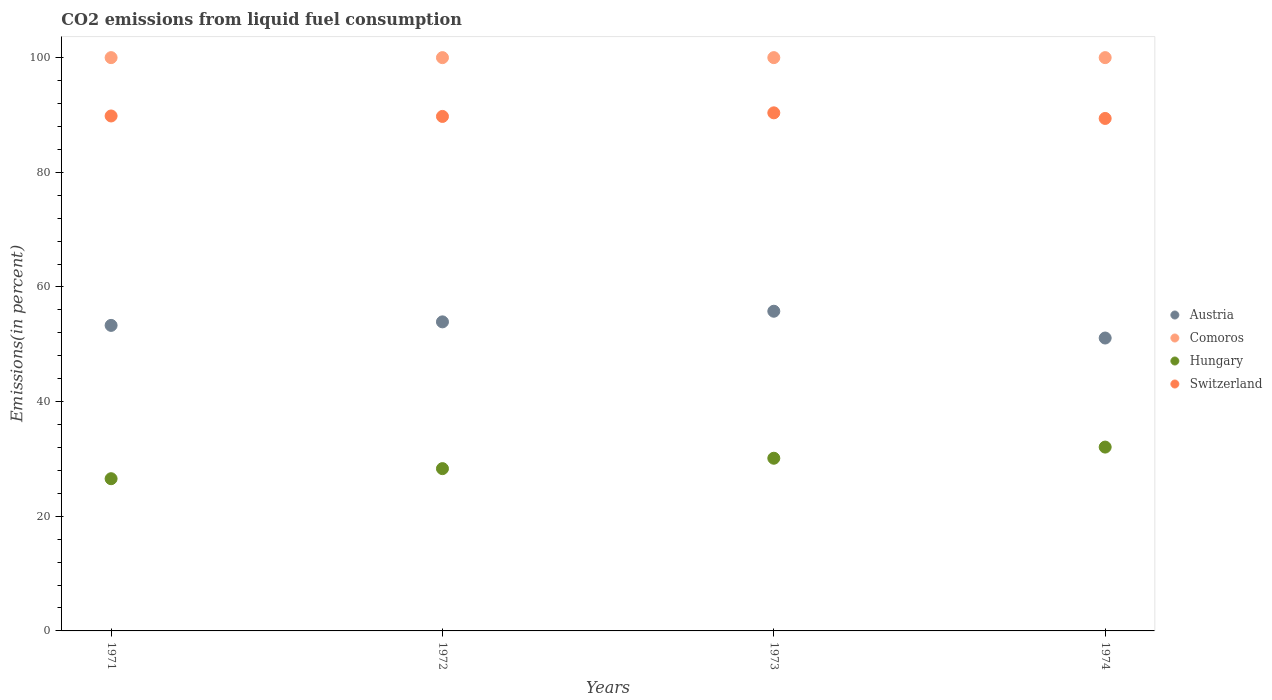How many different coloured dotlines are there?
Keep it short and to the point. 4. What is the total CO2 emitted in Hungary in 1971?
Offer a terse response. 26.55. Across all years, what is the maximum total CO2 emitted in Switzerland?
Give a very brief answer. 90.37. Across all years, what is the minimum total CO2 emitted in Austria?
Your answer should be very brief. 51.09. In which year was the total CO2 emitted in Austria maximum?
Your response must be concise. 1973. In which year was the total CO2 emitted in Switzerland minimum?
Ensure brevity in your answer.  1974. What is the total total CO2 emitted in Switzerland in the graph?
Provide a succinct answer. 359.33. What is the difference between the total CO2 emitted in Hungary in 1972 and that in 1973?
Provide a succinct answer. -1.81. What is the difference between the total CO2 emitted in Austria in 1971 and the total CO2 emitted in Switzerland in 1972?
Give a very brief answer. -36.45. What is the average total CO2 emitted in Switzerland per year?
Provide a short and direct response. 89.83. In the year 1973, what is the difference between the total CO2 emitted in Switzerland and total CO2 emitted in Austria?
Offer a very short reply. 34.61. What is the ratio of the total CO2 emitted in Switzerland in 1972 to that in 1974?
Provide a succinct answer. 1. Is the difference between the total CO2 emitted in Switzerland in 1972 and 1973 greater than the difference between the total CO2 emitted in Austria in 1972 and 1973?
Make the answer very short. Yes. What is the difference between the highest and the second highest total CO2 emitted in Hungary?
Provide a short and direct response. 1.95. What is the difference between the highest and the lowest total CO2 emitted in Comoros?
Provide a short and direct response. 0. Is the sum of the total CO2 emitted in Switzerland in 1971 and 1974 greater than the maximum total CO2 emitted in Austria across all years?
Offer a terse response. Yes. Does the total CO2 emitted in Comoros monotonically increase over the years?
Your answer should be compact. No. How many dotlines are there?
Provide a succinct answer. 4. How many years are there in the graph?
Ensure brevity in your answer.  4. Are the values on the major ticks of Y-axis written in scientific E-notation?
Your answer should be very brief. No. How are the legend labels stacked?
Give a very brief answer. Vertical. What is the title of the graph?
Offer a terse response. CO2 emissions from liquid fuel consumption. What is the label or title of the X-axis?
Offer a terse response. Years. What is the label or title of the Y-axis?
Keep it short and to the point. Emissions(in percent). What is the Emissions(in percent) of Austria in 1971?
Your response must be concise. 53.29. What is the Emissions(in percent) in Comoros in 1971?
Your response must be concise. 100. What is the Emissions(in percent) in Hungary in 1971?
Give a very brief answer. 26.55. What is the Emissions(in percent) in Switzerland in 1971?
Offer a very short reply. 89.82. What is the Emissions(in percent) of Austria in 1972?
Provide a succinct answer. 53.91. What is the Emissions(in percent) in Comoros in 1972?
Your answer should be very brief. 100. What is the Emissions(in percent) in Hungary in 1972?
Your answer should be compact. 28.31. What is the Emissions(in percent) of Switzerland in 1972?
Your answer should be compact. 89.74. What is the Emissions(in percent) in Austria in 1973?
Give a very brief answer. 55.76. What is the Emissions(in percent) of Hungary in 1973?
Your response must be concise. 30.12. What is the Emissions(in percent) in Switzerland in 1973?
Provide a short and direct response. 90.37. What is the Emissions(in percent) in Austria in 1974?
Offer a very short reply. 51.09. What is the Emissions(in percent) of Comoros in 1974?
Provide a succinct answer. 100. What is the Emissions(in percent) in Hungary in 1974?
Offer a terse response. 32.07. What is the Emissions(in percent) of Switzerland in 1974?
Offer a very short reply. 89.39. Across all years, what is the maximum Emissions(in percent) of Austria?
Make the answer very short. 55.76. Across all years, what is the maximum Emissions(in percent) of Hungary?
Give a very brief answer. 32.07. Across all years, what is the maximum Emissions(in percent) in Switzerland?
Give a very brief answer. 90.37. Across all years, what is the minimum Emissions(in percent) of Austria?
Offer a terse response. 51.09. Across all years, what is the minimum Emissions(in percent) in Hungary?
Ensure brevity in your answer.  26.55. Across all years, what is the minimum Emissions(in percent) of Switzerland?
Your answer should be very brief. 89.39. What is the total Emissions(in percent) of Austria in the graph?
Ensure brevity in your answer.  214.06. What is the total Emissions(in percent) of Hungary in the graph?
Make the answer very short. 117.05. What is the total Emissions(in percent) of Switzerland in the graph?
Provide a succinct answer. 359.33. What is the difference between the Emissions(in percent) in Austria in 1971 and that in 1972?
Provide a succinct answer. -0.61. What is the difference between the Emissions(in percent) of Comoros in 1971 and that in 1972?
Give a very brief answer. 0. What is the difference between the Emissions(in percent) in Hungary in 1971 and that in 1972?
Provide a short and direct response. -1.76. What is the difference between the Emissions(in percent) in Switzerland in 1971 and that in 1972?
Give a very brief answer. 0.08. What is the difference between the Emissions(in percent) in Austria in 1971 and that in 1973?
Your response must be concise. -2.47. What is the difference between the Emissions(in percent) in Hungary in 1971 and that in 1973?
Give a very brief answer. -3.57. What is the difference between the Emissions(in percent) of Switzerland in 1971 and that in 1973?
Keep it short and to the point. -0.55. What is the difference between the Emissions(in percent) in Austria in 1971 and that in 1974?
Your answer should be very brief. 2.2. What is the difference between the Emissions(in percent) of Hungary in 1971 and that in 1974?
Provide a short and direct response. -5.52. What is the difference between the Emissions(in percent) of Switzerland in 1971 and that in 1974?
Your answer should be very brief. 0.43. What is the difference between the Emissions(in percent) in Austria in 1972 and that in 1973?
Provide a short and direct response. -1.85. What is the difference between the Emissions(in percent) of Comoros in 1972 and that in 1973?
Your answer should be compact. 0. What is the difference between the Emissions(in percent) in Hungary in 1972 and that in 1973?
Keep it short and to the point. -1.81. What is the difference between the Emissions(in percent) in Switzerland in 1972 and that in 1973?
Ensure brevity in your answer.  -0.63. What is the difference between the Emissions(in percent) of Austria in 1972 and that in 1974?
Your response must be concise. 2.82. What is the difference between the Emissions(in percent) of Hungary in 1972 and that in 1974?
Make the answer very short. -3.76. What is the difference between the Emissions(in percent) of Switzerland in 1972 and that in 1974?
Provide a short and direct response. 0.35. What is the difference between the Emissions(in percent) of Austria in 1973 and that in 1974?
Offer a very short reply. 4.67. What is the difference between the Emissions(in percent) of Hungary in 1973 and that in 1974?
Your response must be concise. -1.95. What is the difference between the Emissions(in percent) in Switzerland in 1973 and that in 1974?
Make the answer very short. 0.98. What is the difference between the Emissions(in percent) of Austria in 1971 and the Emissions(in percent) of Comoros in 1972?
Offer a very short reply. -46.71. What is the difference between the Emissions(in percent) of Austria in 1971 and the Emissions(in percent) of Hungary in 1972?
Keep it short and to the point. 24.99. What is the difference between the Emissions(in percent) of Austria in 1971 and the Emissions(in percent) of Switzerland in 1972?
Make the answer very short. -36.45. What is the difference between the Emissions(in percent) in Comoros in 1971 and the Emissions(in percent) in Hungary in 1972?
Your answer should be compact. 71.69. What is the difference between the Emissions(in percent) in Comoros in 1971 and the Emissions(in percent) in Switzerland in 1972?
Your answer should be very brief. 10.26. What is the difference between the Emissions(in percent) of Hungary in 1971 and the Emissions(in percent) of Switzerland in 1972?
Your answer should be very brief. -63.19. What is the difference between the Emissions(in percent) in Austria in 1971 and the Emissions(in percent) in Comoros in 1973?
Your answer should be compact. -46.71. What is the difference between the Emissions(in percent) in Austria in 1971 and the Emissions(in percent) in Hungary in 1973?
Your answer should be compact. 23.17. What is the difference between the Emissions(in percent) in Austria in 1971 and the Emissions(in percent) in Switzerland in 1973?
Provide a short and direct response. -37.08. What is the difference between the Emissions(in percent) in Comoros in 1971 and the Emissions(in percent) in Hungary in 1973?
Provide a succinct answer. 69.88. What is the difference between the Emissions(in percent) of Comoros in 1971 and the Emissions(in percent) of Switzerland in 1973?
Keep it short and to the point. 9.63. What is the difference between the Emissions(in percent) of Hungary in 1971 and the Emissions(in percent) of Switzerland in 1973?
Your response must be concise. -63.82. What is the difference between the Emissions(in percent) in Austria in 1971 and the Emissions(in percent) in Comoros in 1974?
Offer a very short reply. -46.71. What is the difference between the Emissions(in percent) in Austria in 1971 and the Emissions(in percent) in Hungary in 1974?
Offer a terse response. 21.23. What is the difference between the Emissions(in percent) in Austria in 1971 and the Emissions(in percent) in Switzerland in 1974?
Offer a terse response. -36.1. What is the difference between the Emissions(in percent) of Comoros in 1971 and the Emissions(in percent) of Hungary in 1974?
Your response must be concise. 67.93. What is the difference between the Emissions(in percent) in Comoros in 1971 and the Emissions(in percent) in Switzerland in 1974?
Ensure brevity in your answer.  10.61. What is the difference between the Emissions(in percent) of Hungary in 1971 and the Emissions(in percent) of Switzerland in 1974?
Keep it short and to the point. -62.84. What is the difference between the Emissions(in percent) of Austria in 1972 and the Emissions(in percent) of Comoros in 1973?
Make the answer very short. -46.09. What is the difference between the Emissions(in percent) of Austria in 1972 and the Emissions(in percent) of Hungary in 1973?
Your answer should be compact. 23.79. What is the difference between the Emissions(in percent) of Austria in 1972 and the Emissions(in percent) of Switzerland in 1973?
Offer a very short reply. -36.46. What is the difference between the Emissions(in percent) in Comoros in 1972 and the Emissions(in percent) in Hungary in 1973?
Offer a terse response. 69.88. What is the difference between the Emissions(in percent) in Comoros in 1972 and the Emissions(in percent) in Switzerland in 1973?
Offer a terse response. 9.63. What is the difference between the Emissions(in percent) of Hungary in 1972 and the Emissions(in percent) of Switzerland in 1973?
Your response must be concise. -62.06. What is the difference between the Emissions(in percent) in Austria in 1972 and the Emissions(in percent) in Comoros in 1974?
Offer a very short reply. -46.09. What is the difference between the Emissions(in percent) of Austria in 1972 and the Emissions(in percent) of Hungary in 1974?
Your response must be concise. 21.84. What is the difference between the Emissions(in percent) in Austria in 1972 and the Emissions(in percent) in Switzerland in 1974?
Offer a terse response. -35.48. What is the difference between the Emissions(in percent) in Comoros in 1972 and the Emissions(in percent) in Hungary in 1974?
Give a very brief answer. 67.93. What is the difference between the Emissions(in percent) in Comoros in 1972 and the Emissions(in percent) in Switzerland in 1974?
Your answer should be very brief. 10.61. What is the difference between the Emissions(in percent) of Hungary in 1972 and the Emissions(in percent) of Switzerland in 1974?
Provide a succinct answer. -61.08. What is the difference between the Emissions(in percent) of Austria in 1973 and the Emissions(in percent) of Comoros in 1974?
Make the answer very short. -44.24. What is the difference between the Emissions(in percent) of Austria in 1973 and the Emissions(in percent) of Hungary in 1974?
Your answer should be very brief. 23.7. What is the difference between the Emissions(in percent) of Austria in 1973 and the Emissions(in percent) of Switzerland in 1974?
Give a very brief answer. -33.63. What is the difference between the Emissions(in percent) of Comoros in 1973 and the Emissions(in percent) of Hungary in 1974?
Give a very brief answer. 67.93. What is the difference between the Emissions(in percent) of Comoros in 1973 and the Emissions(in percent) of Switzerland in 1974?
Keep it short and to the point. 10.61. What is the difference between the Emissions(in percent) in Hungary in 1973 and the Emissions(in percent) in Switzerland in 1974?
Your response must be concise. -59.27. What is the average Emissions(in percent) in Austria per year?
Provide a short and direct response. 53.51. What is the average Emissions(in percent) of Comoros per year?
Offer a very short reply. 100. What is the average Emissions(in percent) of Hungary per year?
Make the answer very short. 29.26. What is the average Emissions(in percent) in Switzerland per year?
Your response must be concise. 89.83. In the year 1971, what is the difference between the Emissions(in percent) of Austria and Emissions(in percent) of Comoros?
Your response must be concise. -46.71. In the year 1971, what is the difference between the Emissions(in percent) of Austria and Emissions(in percent) of Hungary?
Your answer should be very brief. 26.74. In the year 1971, what is the difference between the Emissions(in percent) in Austria and Emissions(in percent) in Switzerland?
Your response must be concise. -36.53. In the year 1971, what is the difference between the Emissions(in percent) of Comoros and Emissions(in percent) of Hungary?
Your answer should be very brief. 73.45. In the year 1971, what is the difference between the Emissions(in percent) of Comoros and Emissions(in percent) of Switzerland?
Keep it short and to the point. 10.18. In the year 1971, what is the difference between the Emissions(in percent) of Hungary and Emissions(in percent) of Switzerland?
Give a very brief answer. -63.27. In the year 1972, what is the difference between the Emissions(in percent) in Austria and Emissions(in percent) in Comoros?
Provide a succinct answer. -46.09. In the year 1972, what is the difference between the Emissions(in percent) in Austria and Emissions(in percent) in Hungary?
Your answer should be very brief. 25.6. In the year 1972, what is the difference between the Emissions(in percent) in Austria and Emissions(in percent) in Switzerland?
Make the answer very short. -35.83. In the year 1972, what is the difference between the Emissions(in percent) in Comoros and Emissions(in percent) in Hungary?
Give a very brief answer. 71.69. In the year 1972, what is the difference between the Emissions(in percent) of Comoros and Emissions(in percent) of Switzerland?
Provide a succinct answer. 10.26. In the year 1972, what is the difference between the Emissions(in percent) in Hungary and Emissions(in percent) in Switzerland?
Provide a succinct answer. -61.43. In the year 1973, what is the difference between the Emissions(in percent) in Austria and Emissions(in percent) in Comoros?
Offer a terse response. -44.24. In the year 1973, what is the difference between the Emissions(in percent) in Austria and Emissions(in percent) in Hungary?
Make the answer very short. 25.64. In the year 1973, what is the difference between the Emissions(in percent) of Austria and Emissions(in percent) of Switzerland?
Provide a short and direct response. -34.61. In the year 1973, what is the difference between the Emissions(in percent) of Comoros and Emissions(in percent) of Hungary?
Offer a terse response. 69.88. In the year 1973, what is the difference between the Emissions(in percent) of Comoros and Emissions(in percent) of Switzerland?
Offer a terse response. 9.63. In the year 1973, what is the difference between the Emissions(in percent) in Hungary and Emissions(in percent) in Switzerland?
Your answer should be very brief. -60.25. In the year 1974, what is the difference between the Emissions(in percent) in Austria and Emissions(in percent) in Comoros?
Your response must be concise. -48.91. In the year 1974, what is the difference between the Emissions(in percent) of Austria and Emissions(in percent) of Hungary?
Your answer should be compact. 19.02. In the year 1974, what is the difference between the Emissions(in percent) in Austria and Emissions(in percent) in Switzerland?
Your answer should be very brief. -38.3. In the year 1974, what is the difference between the Emissions(in percent) of Comoros and Emissions(in percent) of Hungary?
Give a very brief answer. 67.93. In the year 1974, what is the difference between the Emissions(in percent) of Comoros and Emissions(in percent) of Switzerland?
Offer a terse response. 10.61. In the year 1974, what is the difference between the Emissions(in percent) of Hungary and Emissions(in percent) of Switzerland?
Your answer should be compact. -57.33. What is the ratio of the Emissions(in percent) of Austria in 1971 to that in 1972?
Keep it short and to the point. 0.99. What is the ratio of the Emissions(in percent) in Comoros in 1971 to that in 1972?
Your response must be concise. 1. What is the ratio of the Emissions(in percent) of Hungary in 1971 to that in 1972?
Provide a succinct answer. 0.94. What is the ratio of the Emissions(in percent) of Austria in 1971 to that in 1973?
Provide a succinct answer. 0.96. What is the ratio of the Emissions(in percent) in Hungary in 1971 to that in 1973?
Your response must be concise. 0.88. What is the ratio of the Emissions(in percent) of Switzerland in 1971 to that in 1973?
Your response must be concise. 0.99. What is the ratio of the Emissions(in percent) of Austria in 1971 to that in 1974?
Give a very brief answer. 1.04. What is the ratio of the Emissions(in percent) in Comoros in 1971 to that in 1974?
Your response must be concise. 1. What is the ratio of the Emissions(in percent) in Hungary in 1971 to that in 1974?
Provide a succinct answer. 0.83. What is the ratio of the Emissions(in percent) of Austria in 1972 to that in 1973?
Make the answer very short. 0.97. What is the ratio of the Emissions(in percent) of Hungary in 1972 to that in 1973?
Make the answer very short. 0.94. What is the ratio of the Emissions(in percent) of Austria in 1972 to that in 1974?
Your answer should be very brief. 1.06. What is the ratio of the Emissions(in percent) in Comoros in 1972 to that in 1974?
Provide a short and direct response. 1. What is the ratio of the Emissions(in percent) of Hungary in 1972 to that in 1974?
Your answer should be very brief. 0.88. What is the ratio of the Emissions(in percent) of Austria in 1973 to that in 1974?
Offer a very short reply. 1.09. What is the ratio of the Emissions(in percent) in Hungary in 1973 to that in 1974?
Your answer should be compact. 0.94. What is the ratio of the Emissions(in percent) in Switzerland in 1973 to that in 1974?
Provide a short and direct response. 1.01. What is the difference between the highest and the second highest Emissions(in percent) in Austria?
Ensure brevity in your answer.  1.85. What is the difference between the highest and the second highest Emissions(in percent) of Hungary?
Your response must be concise. 1.95. What is the difference between the highest and the second highest Emissions(in percent) in Switzerland?
Provide a short and direct response. 0.55. What is the difference between the highest and the lowest Emissions(in percent) of Austria?
Your answer should be compact. 4.67. What is the difference between the highest and the lowest Emissions(in percent) of Comoros?
Your answer should be compact. 0. What is the difference between the highest and the lowest Emissions(in percent) of Hungary?
Your answer should be very brief. 5.52. What is the difference between the highest and the lowest Emissions(in percent) of Switzerland?
Provide a short and direct response. 0.98. 